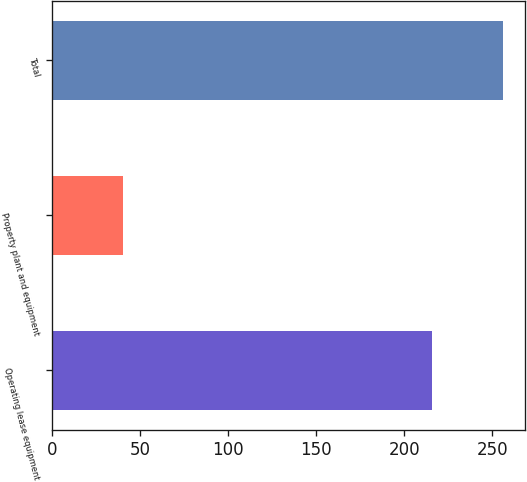Convert chart. <chart><loc_0><loc_0><loc_500><loc_500><bar_chart><fcel>Operating lease equipment<fcel>Property plant and equipment<fcel>Total<nl><fcel>216<fcel>40<fcel>256<nl></chart> 